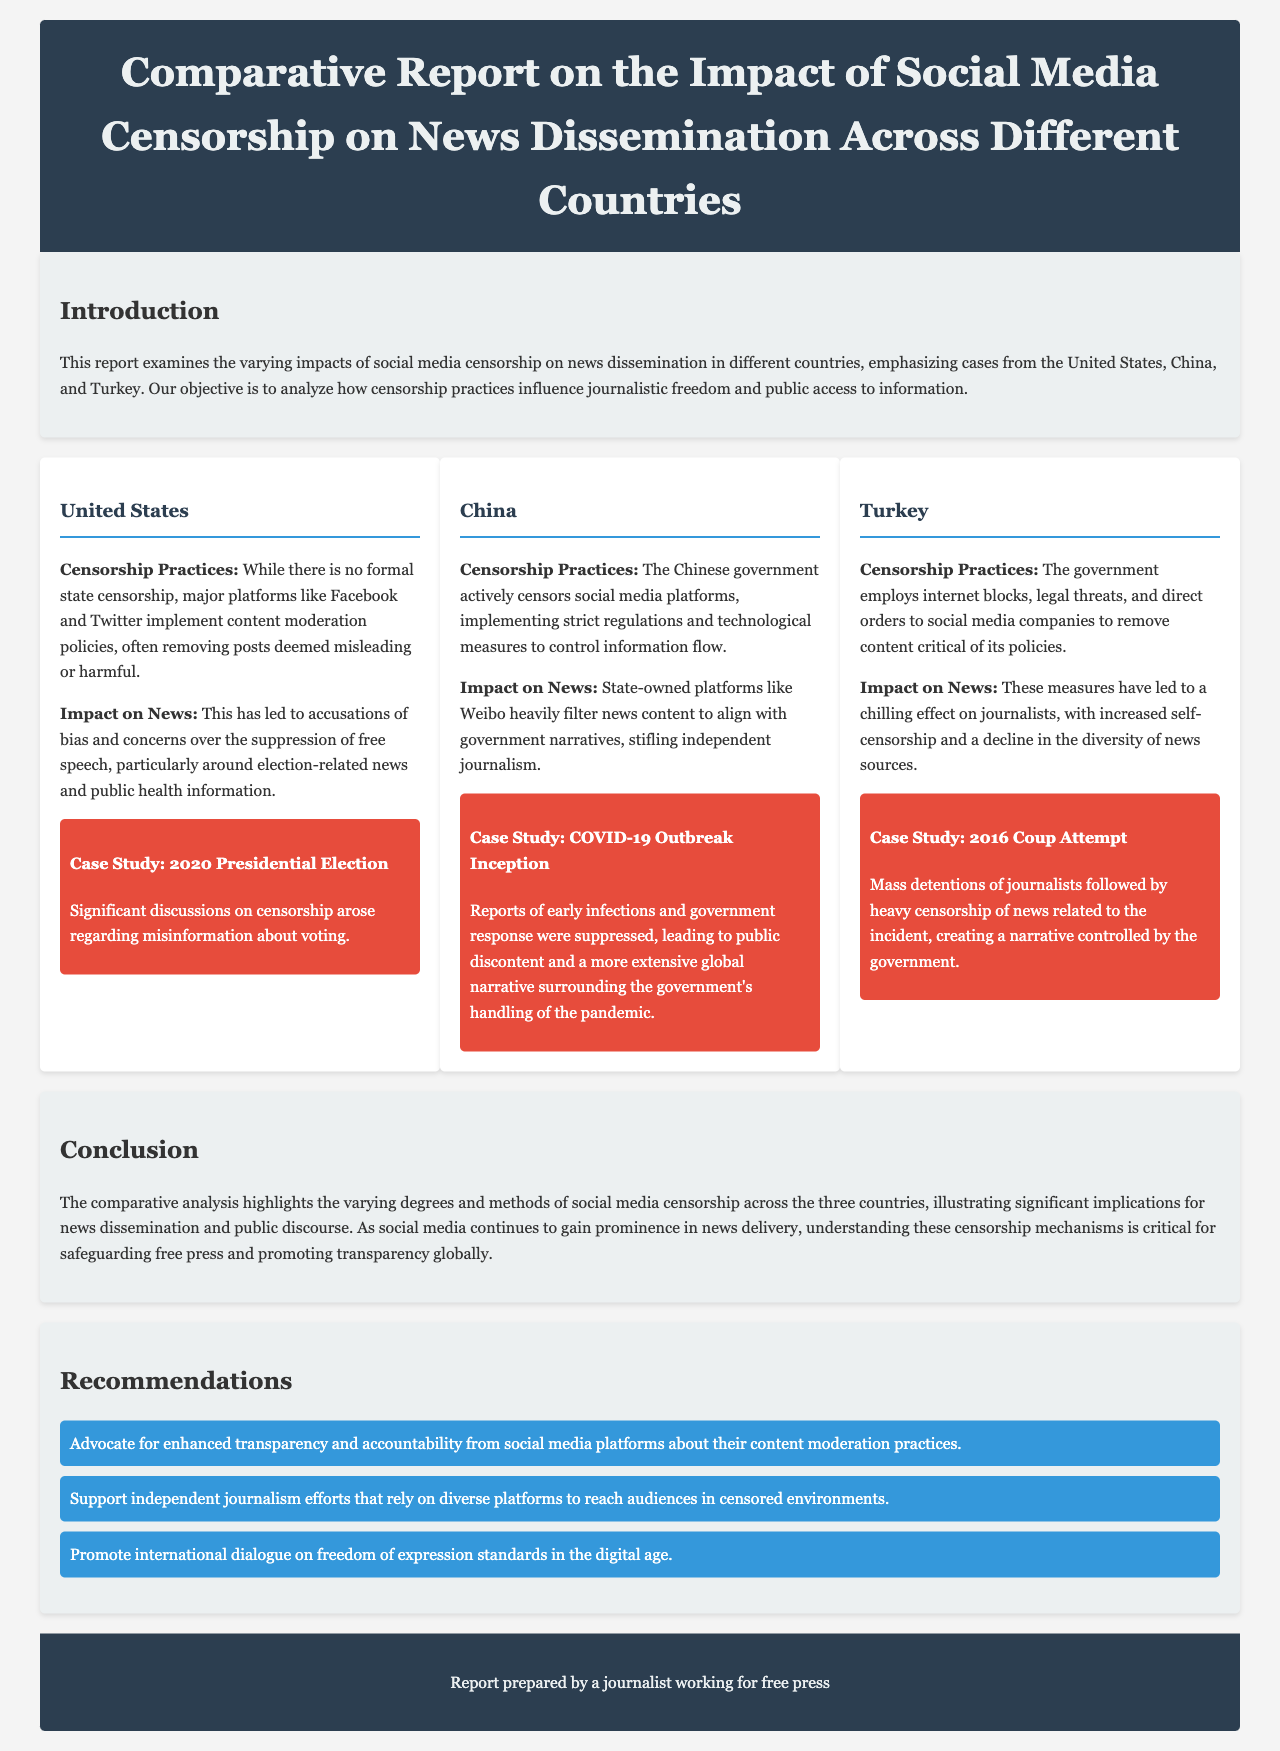What countries are analyzed in the report? The report examines the impact of social media censorship on news dissemination in the United States, China, and Turkey.
Answer: United States, China, Turkey What is a key issue in the United States regarding social media censorship? The report mentions accusations of bias and concerns over the suppression of free speech, particularly around election-related news and public health information.
Answer: Suppression of free speech What form of censorship is practiced by the Chinese government? The Chinese government actively censors social media platforms, implementing strict regulations and technological measures to control information flow.
Answer: Strict regulations What significant event does the report highlight in Turkey? The report discusses the mass detentions of journalists following the 2016 Coup Attempt and the heavy censorship of news related to the incident.
Answer: 2016 Coup Attempt What is one recommendation given in the report? The report suggests supporting independent journalism efforts that rely on diverse platforms to reach audiences in censored environments.
Answer: Support independent journalism What effect does censorship have on journalists in Turkey? The measures employed by the government have led to a chilling effect on journalists, with increased self-censorship and a decline in the diversity of news sources.
Answer: Chilling effect What is the objective of the report? The objective is to analyze how censorship practices influence journalistic freedom and public access to information.
Answer: Analyze censorship influence What was suppressed during the COVID-19 outbreak in China? Reports of early infections and government response were suppressed, leading to public discontent.
Answer: Early infections and government response 